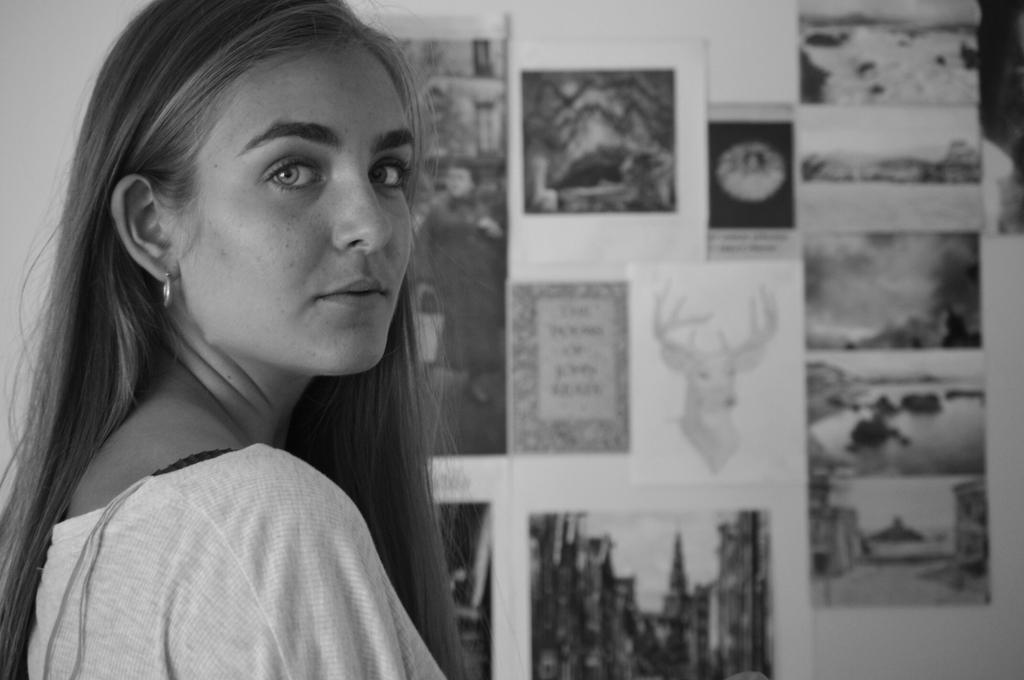Who is present in the image? There is a woman in the image. What can be seen on the board in the image? There are photos on a board in the image. What type of nation is depicted in the image? There is no nation depicted in the image; it features a woman and photos on a board. What is the woman using to eat her meal in the image? There is no meal or fork present in the image. 